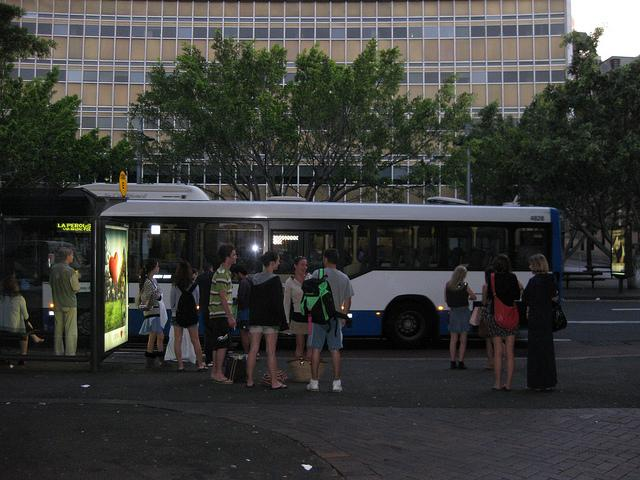Why are they standing on the sidewalk? Please explain your reasoning. taking bus. The people are waiting on the sidewalk so they are likely about to board the bus. 